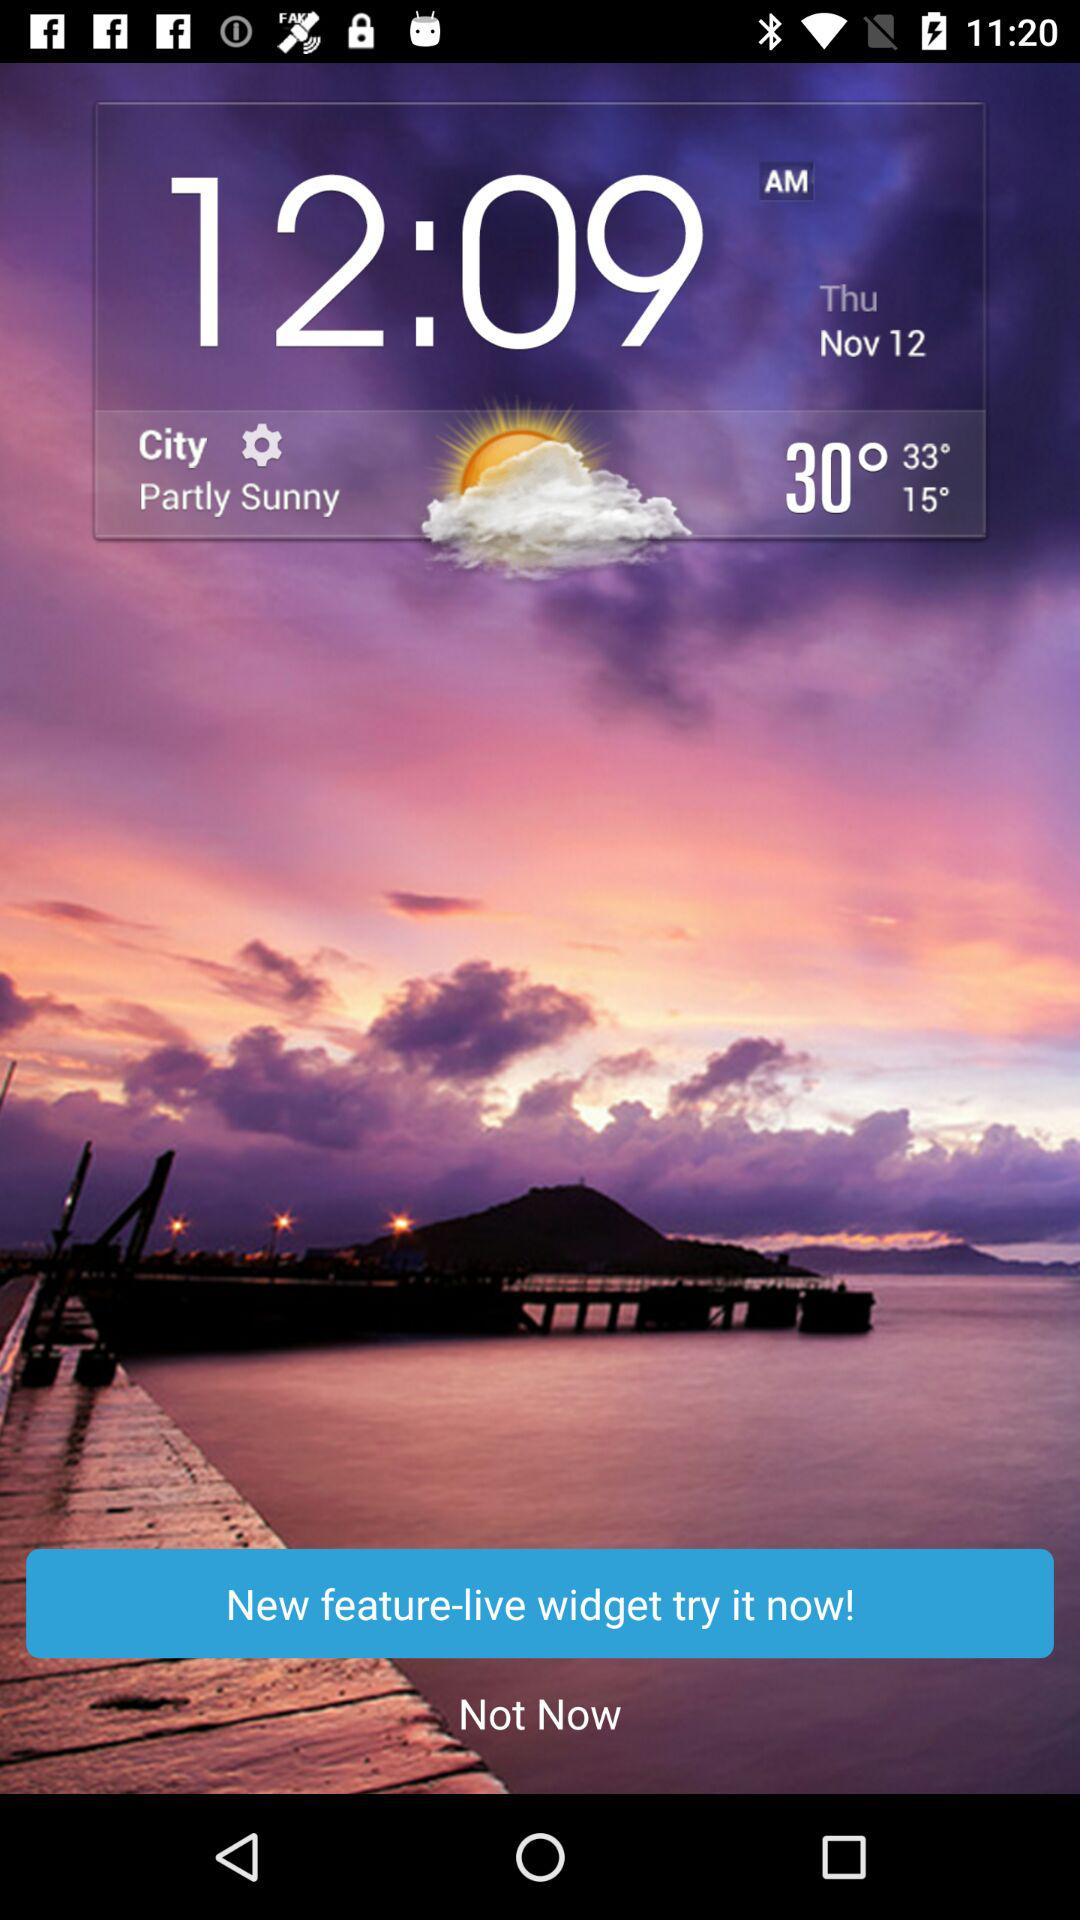What is the date? The date is Thursday, November 12. 